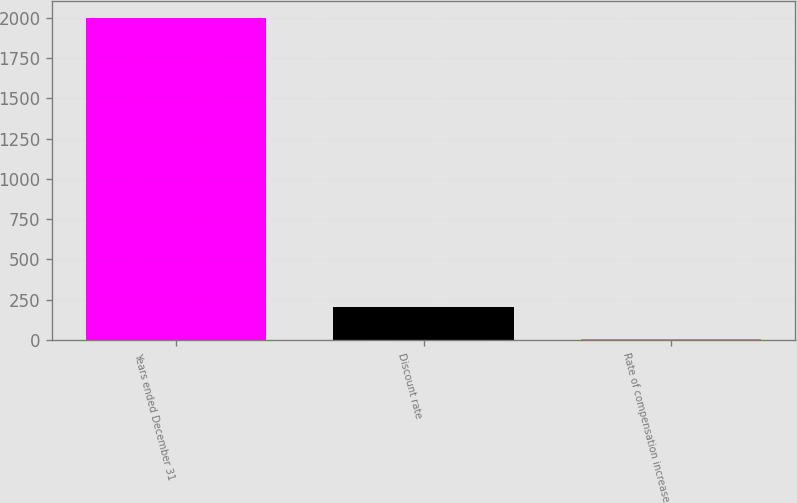Convert chart. <chart><loc_0><loc_0><loc_500><loc_500><bar_chart><fcel>Years ended December 31<fcel>Discount rate<fcel>Rate of compensation increase<nl><fcel>2003<fcel>203.9<fcel>4<nl></chart> 